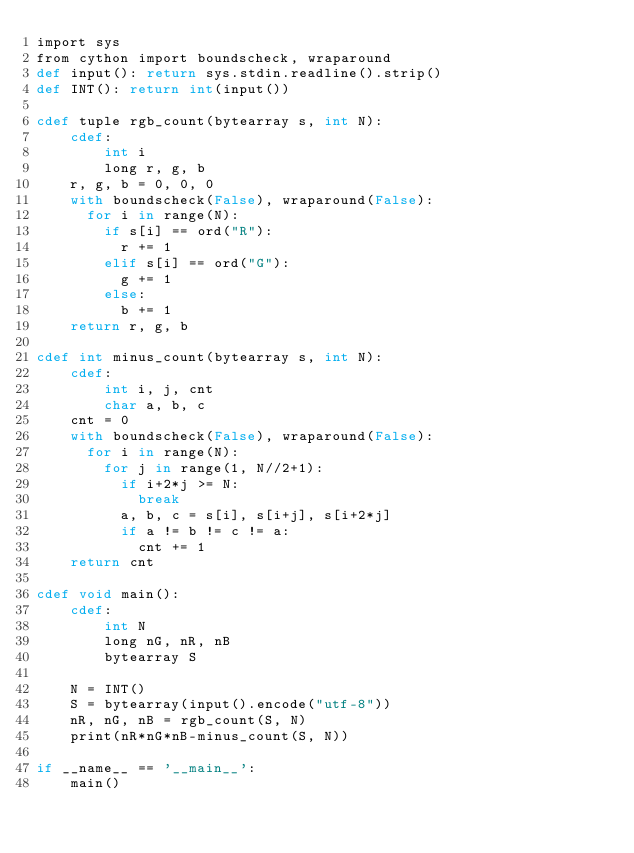Convert code to text. <code><loc_0><loc_0><loc_500><loc_500><_Cython_>import sys
from cython import boundscheck, wraparound
def input(): return sys.stdin.readline().strip()
def INT(): return int(input())
 
cdef tuple rgb_count(bytearray s, int N):
    cdef:
        int i
        long r, g, b
    r, g, b = 0, 0, 0
    with boundscheck(False), wraparound(False):
      for i in range(N):
        if s[i] == ord("R"):
          r += 1
        elif s[i] == ord("G"):
          g += 1
        else:
          b += 1
    return r, g, b
 
cdef int minus_count(bytearray s, int N):
    cdef:
        int i, j, cnt
        char a, b, c
    cnt = 0
    with boundscheck(False), wraparound(False):
      for i in range(N):
        for j in range(1, N//2+1):
          if i+2*j >= N:
            break
          a, b, c = s[i], s[i+j], s[i+2*j]
          if a != b != c != a:
            cnt += 1
    return cnt
 
cdef void main():
    cdef:
        int N
        long nG, nR, nB
        bytearray S
 
    N = INT()
    S = bytearray(input().encode("utf-8"))
    nR, nG, nB = rgb_count(S, N)
    print(nR*nG*nB-minus_count(S, N))
 
if __name__ == '__main__':
    main()
</code> 